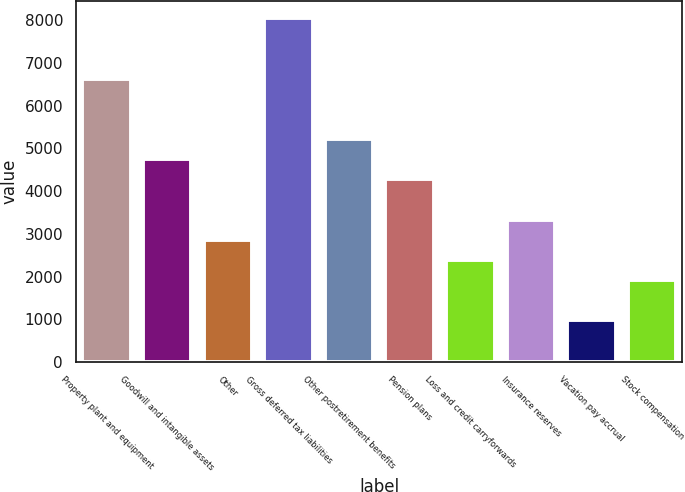Convert chart. <chart><loc_0><loc_0><loc_500><loc_500><bar_chart><fcel>Property plant and equipment<fcel>Goodwill and intangible assets<fcel>Other<fcel>Gross deferred tax liabilities<fcel>Other postretirement benefits<fcel>Pension plans<fcel>Loss and credit carryforwards<fcel>Insurance reserves<fcel>Vacation pay accrual<fcel>Stock compensation<nl><fcel>6638.8<fcel>4750<fcel>2861.2<fcel>8055.4<fcel>5222.2<fcel>4277.8<fcel>2389<fcel>3333.4<fcel>972.4<fcel>1916.8<nl></chart> 